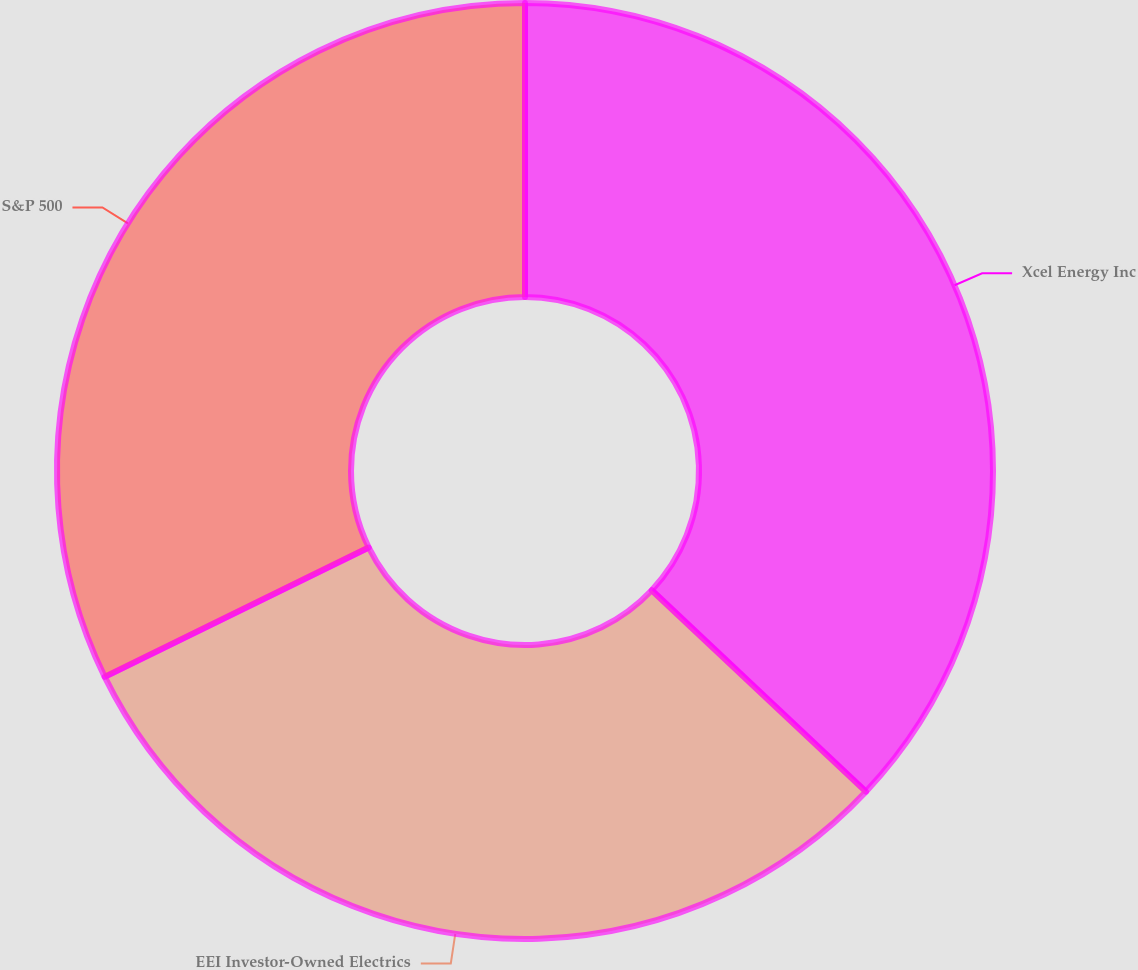Convert chart. <chart><loc_0><loc_0><loc_500><loc_500><pie_chart><fcel>Xcel Energy Inc<fcel>EEI Investor-Owned Electrics<fcel>S&P 500<nl><fcel>37.01%<fcel>30.74%<fcel>32.25%<nl></chart> 